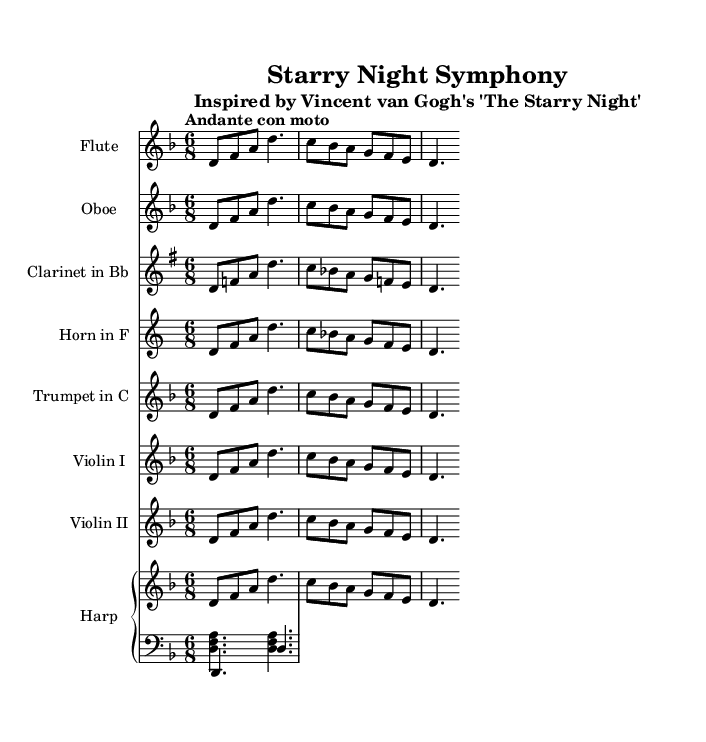What is the key signature of this music? The key signature is D minor, which is indicated by one flat (B-flat) and a signature line that indicates D as the tonic note.
Answer: D minor What is the time signature of this music? The time signature is 6/8, which is shown at the beginning of the score, indicating a compound duple meter with six eighth notes per measure.
Answer: 6/8 What tempo marking is indicated in this symphony? The tempo marking is "Andante con moto," which suggests a moderately slow tempo with a certain lively character.
Answer: Andante con moto How many instruments are included in this symphony? There are seven different instruments listed, including flute, oboe, clarinet, horn, trumpet, violin I, violin II, and harp.
Answer: Seven What is the predominant orchestration technique used in this score? The score employs a technique where the main melody is distributed across multiple instruments, which creates a rich texture and allows for varied timbral qualities.
Answer: Melody distribution How many measures are suggested by the main melody? The main melody spans 4 measures as reflected in the structure of the notation, which aligns with the time signature of 6/8.
Answer: Four measures In which art piece is this symphony inspired? This symphony is inspired by Vincent van Gogh's "The Starry Night," as noted in the subtitle of the score, linking visual art to orchestral music interpretation.
Answer: The Starry Night 